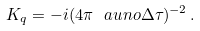<formula> <loc_0><loc_0><loc_500><loc_500>K _ { q } = - i ( 4 \pi \ a u n o \Delta \tau ) ^ { - 2 } \, .</formula> 